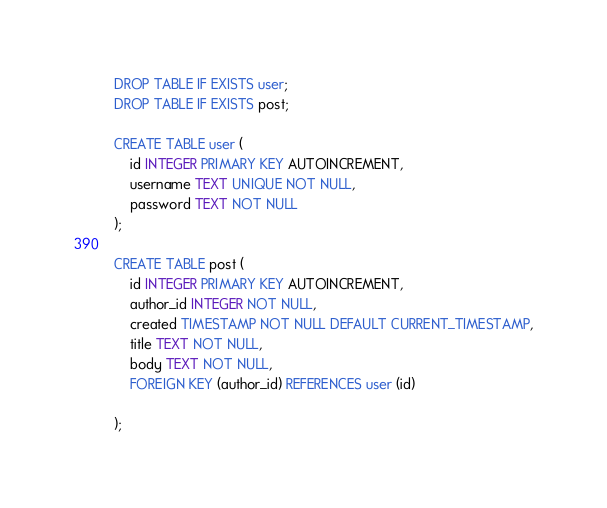<code> <loc_0><loc_0><loc_500><loc_500><_SQL_>DROP TABLE IF EXISTS user; 
DROP TABLE IF EXISTS post; 

CREATE TABLE user (
    id INTEGER PRIMARY KEY AUTOINCREMENT,
    username TEXT UNIQUE NOT NULL, 
    password TEXT NOT NULL
); 

CREATE TABLE post (
    id INTEGER PRIMARY KEY AUTOINCREMENT, 
    author_id INTEGER NOT NULL, 
    created TIMESTAMP NOT NULL DEFAULT CURRENT_TIMESTAMP,
    title TEXT NOT NULL, 
    body TEXT NOT NULL, 
    FOREIGN KEY (author_id) REFERENCES user (id)

);</code> 